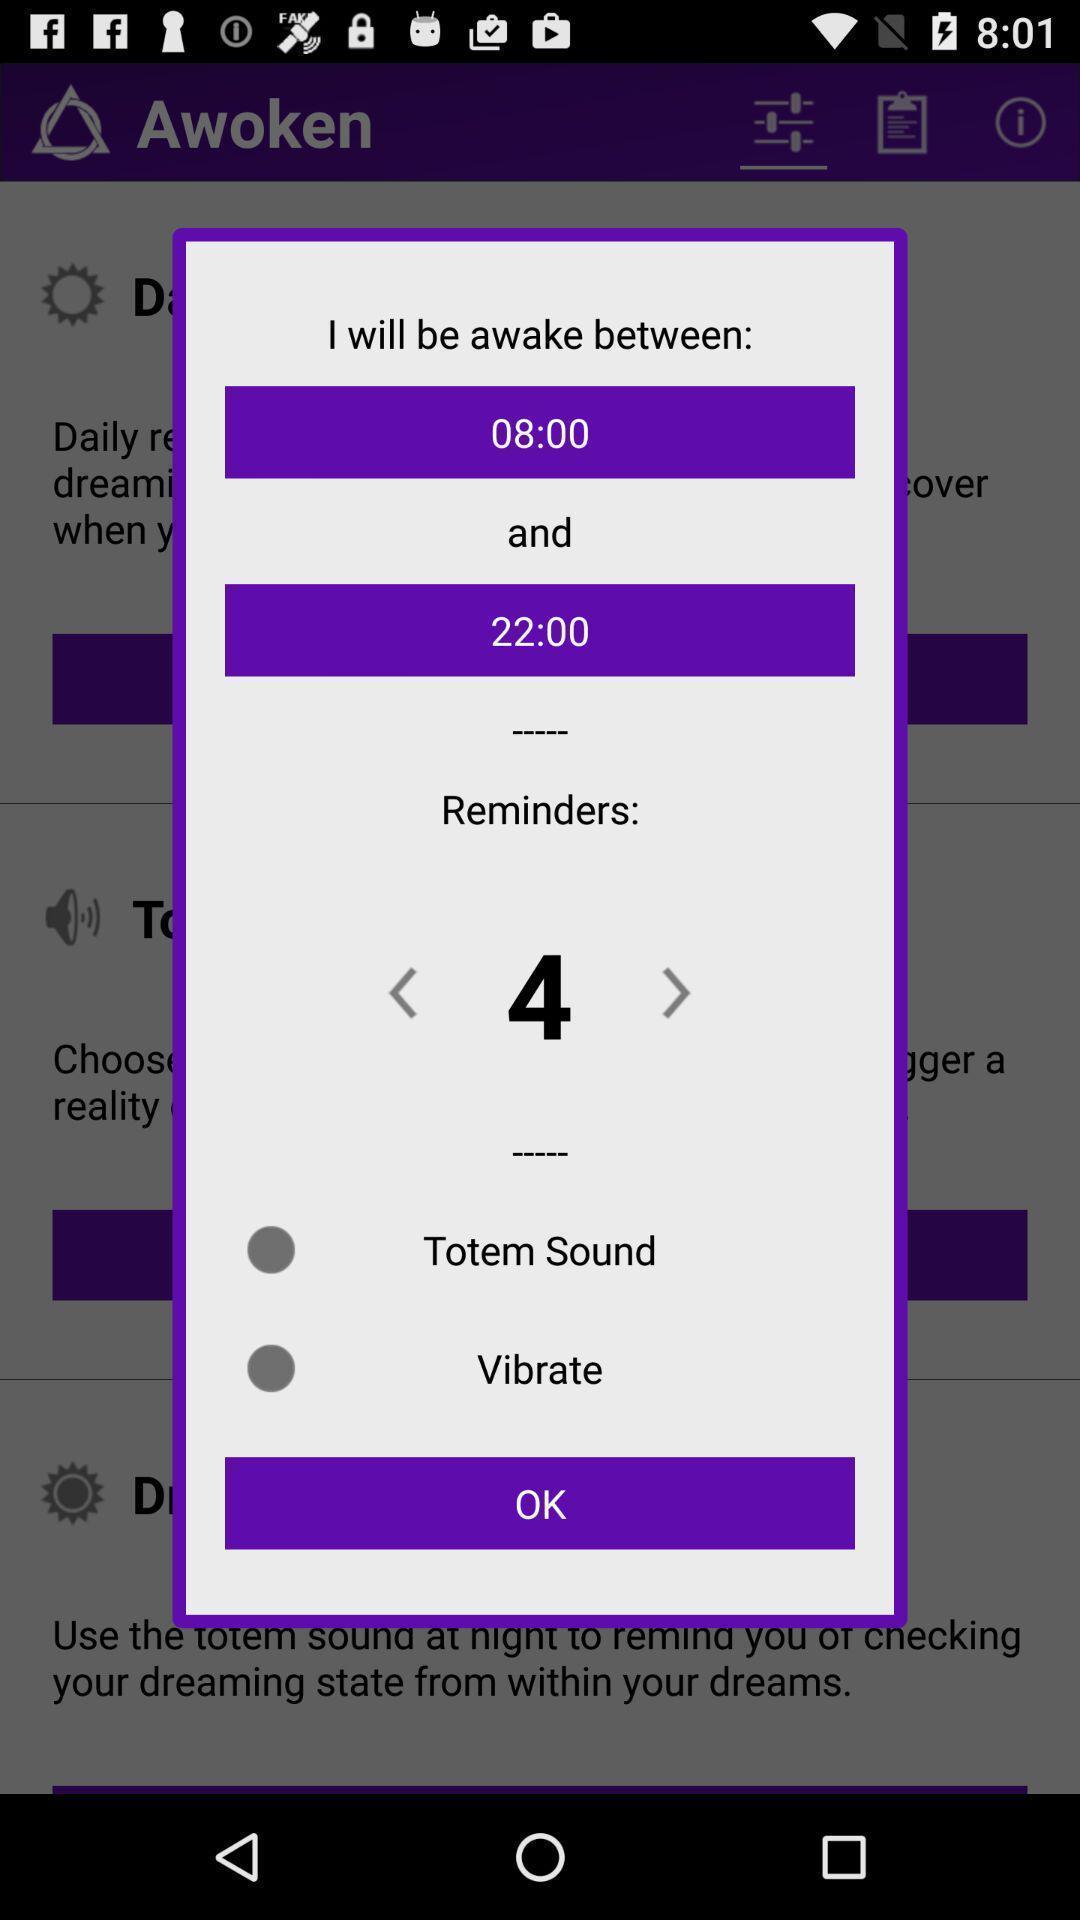What is the overall content of this screenshot? Pop-up showing the wake up reminder details. 